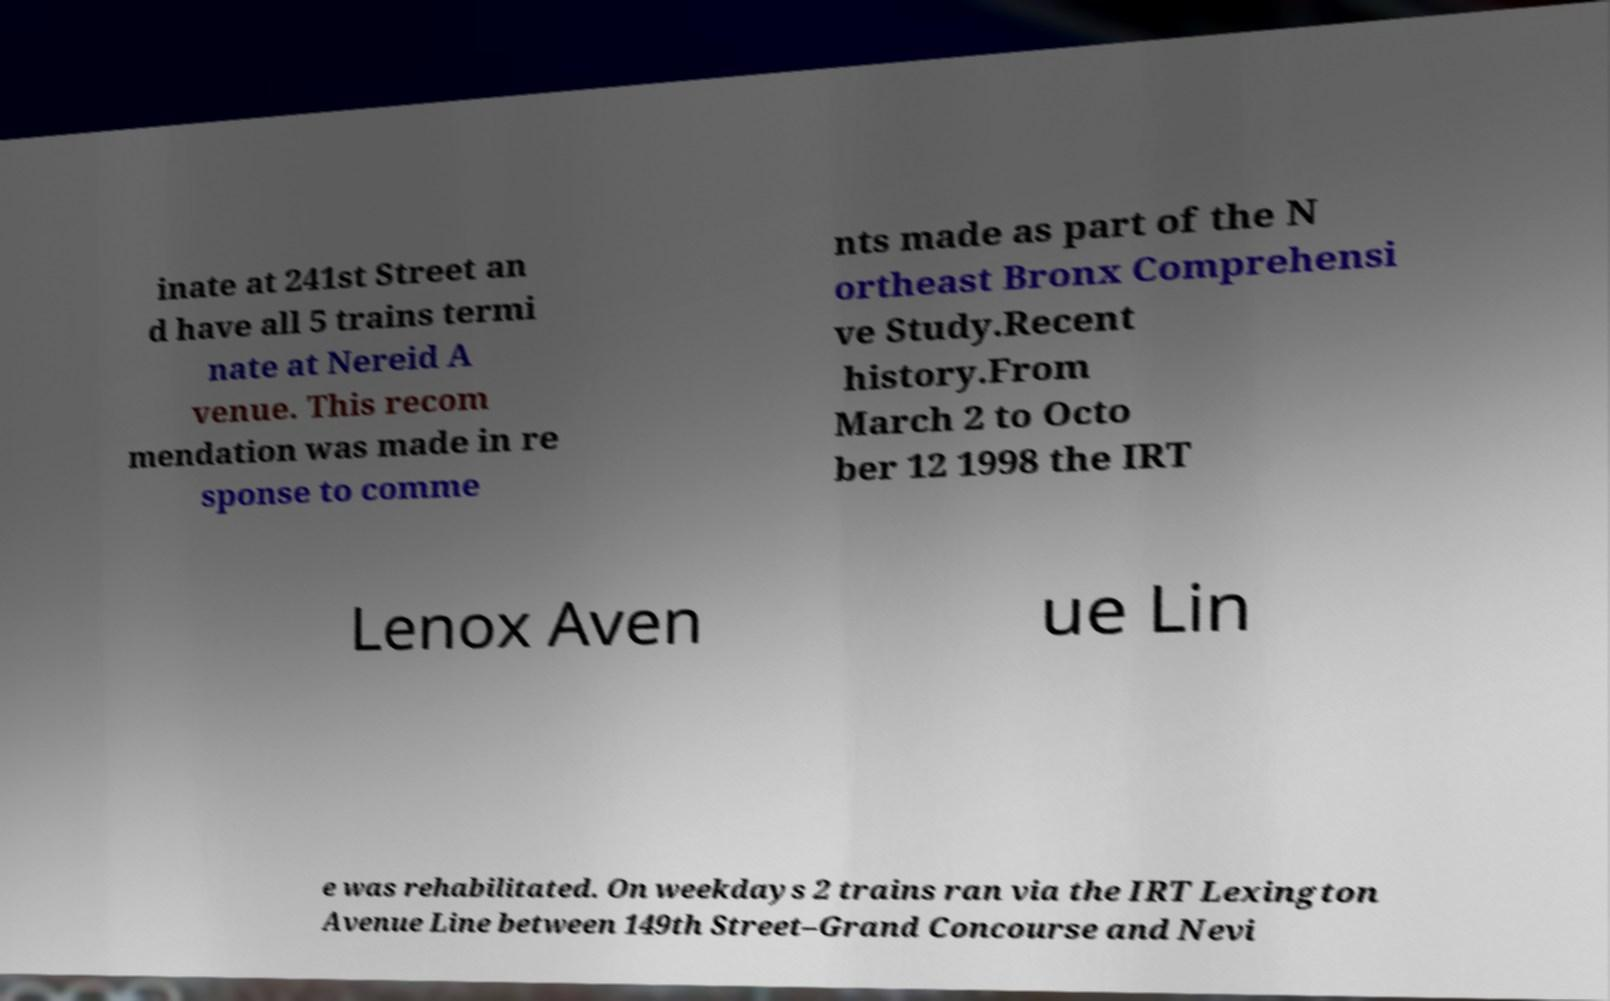There's text embedded in this image that I need extracted. Can you transcribe it verbatim? inate at 241st Street an d have all 5 trains termi nate at Nereid A venue. This recom mendation was made in re sponse to comme nts made as part of the N ortheast Bronx Comprehensi ve Study.Recent history.From March 2 to Octo ber 12 1998 the IRT Lenox Aven ue Lin e was rehabilitated. On weekdays 2 trains ran via the IRT Lexington Avenue Line between 149th Street–Grand Concourse and Nevi 